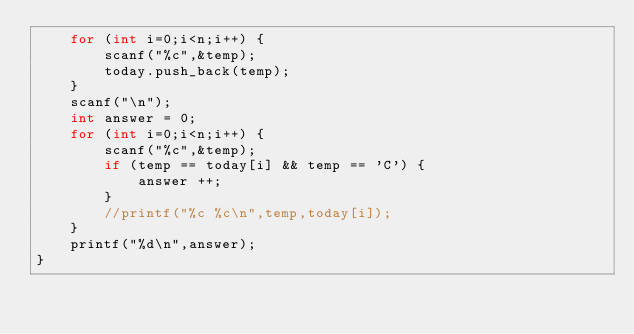<code> <loc_0><loc_0><loc_500><loc_500><_C++_>    for (int i=0;i<n;i++) {
        scanf("%c",&temp);
        today.push_back(temp);
    }
    scanf("\n");
    int answer = 0;
    for (int i=0;i<n;i++) {
        scanf("%c",&temp);
        if (temp == today[i] && temp == 'C') {
            answer ++;
        }
        //printf("%c %c\n",temp,today[i]);
    }
    printf("%d\n",answer);
}
</code> 